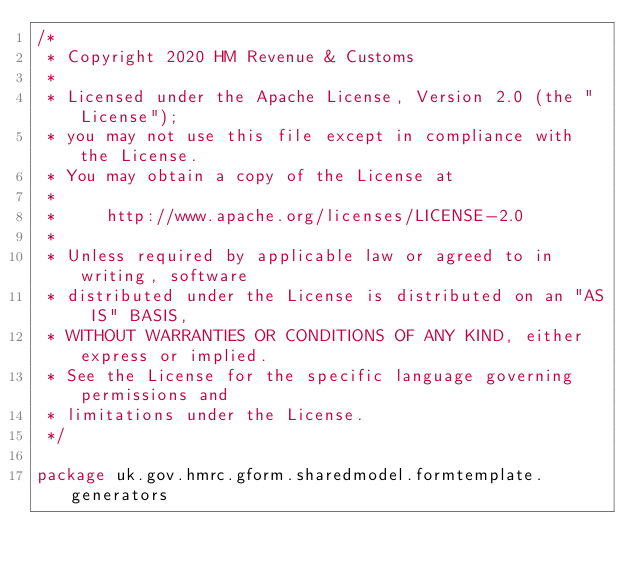Convert code to text. <code><loc_0><loc_0><loc_500><loc_500><_Scala_>/*
 * Copyright 2020 HM Revenue & Customs
 *
 * Licensed under the Apache License, Version 2.0 (the "License");
 * you may not use this file except in compliance with the License.
 * You may obtain a copy of the License at
 *
 *     http://www.apache.org/licenses/LICENSE-2.0
 *
 * Unless required by applicable law or agreed to in writing, software
 * distributed under the License is distributed on an "AS IS" BASIS,
 * WITHOUT WARRANTIES OR CONDITIONS OF ANY KIND, either express or implied.
 * See the License for the specific language governing permissions and
 * limitations under the License.
 */

package uk.gov.hmrc.gform.sharedmodel.formtemplate.generators
</code> 